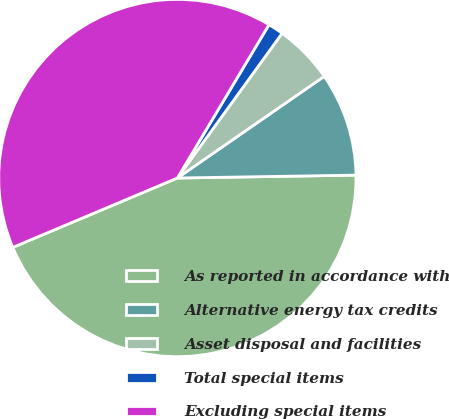Convert chart to OTSL. <chart><loc_0><loc_0><loc_500><loc_500><pie_chart><fcel>As reported in accordance with<fcel>Alternative energy tax credits<fcel>Asset disposal and facilities<fcel>Total special items<fcel>Excluding special items<nl><fcel>43.91%<fcel>9.38%<fcel>5.39%<fcel>1.4%<fcel>39.92%<nl></chart> 